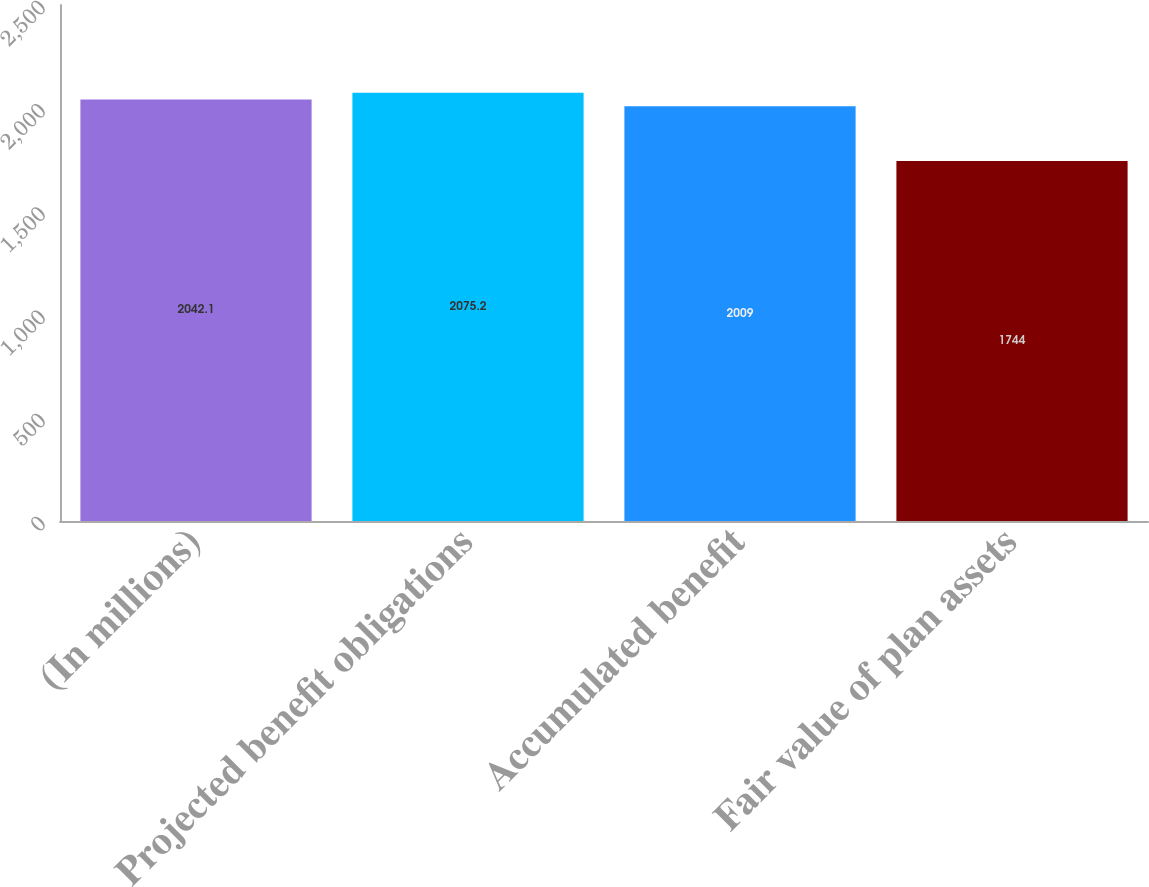Convert chart to OTSL. <chart><loc_0><loc_0><loc_500><loc_500><bar_chart><fcel>(In millions)<fcel>Projected benefit obligations<fcel>Accumulated benefit<fcel>Fair value of plan assets<nl><fcel>2042.1<fcel>2075.2<fcel>2009<fcel>1744<nl></chart> 